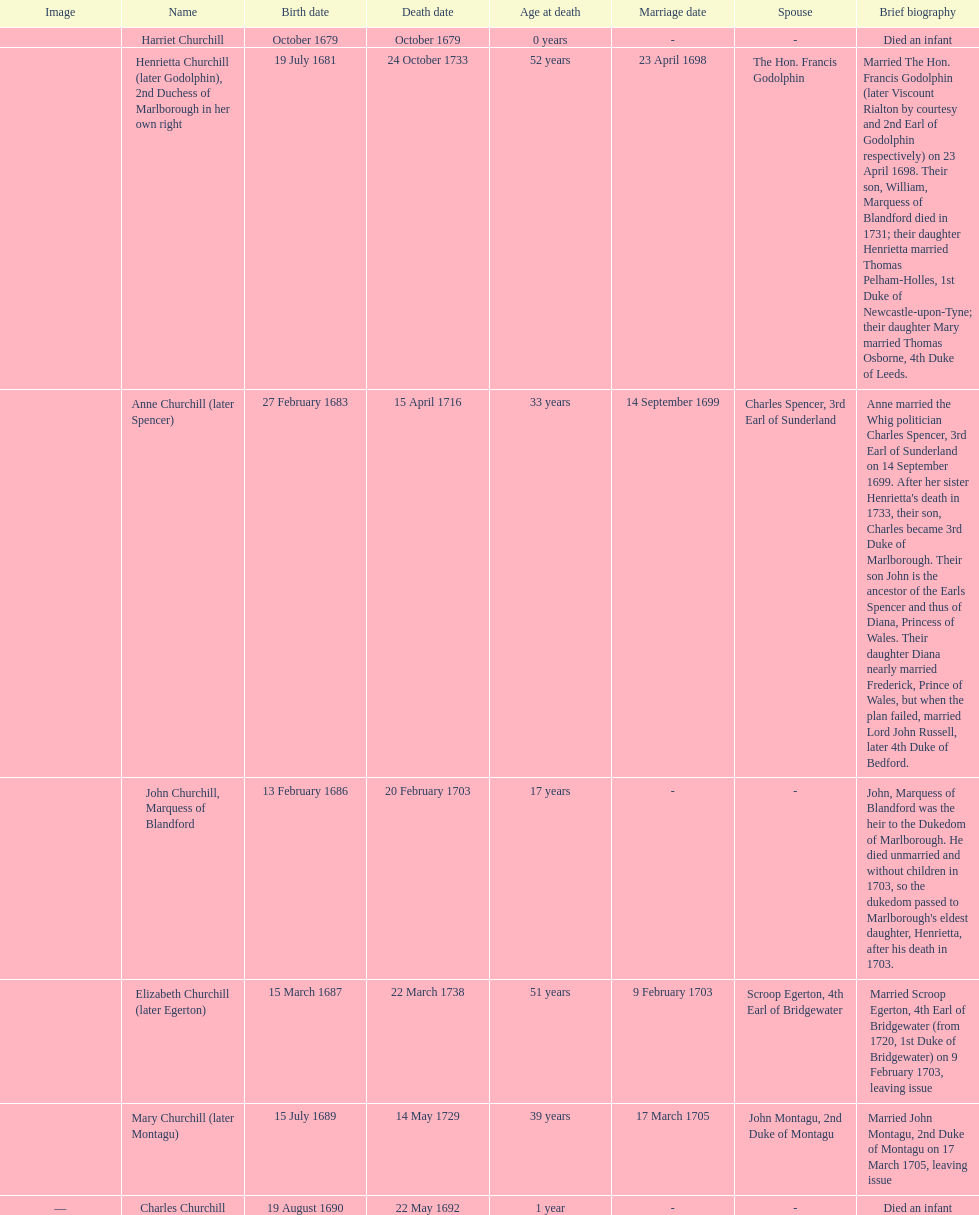Who was born first? mary churchill or elizabeth churchill? Elizabeth Churchill. 